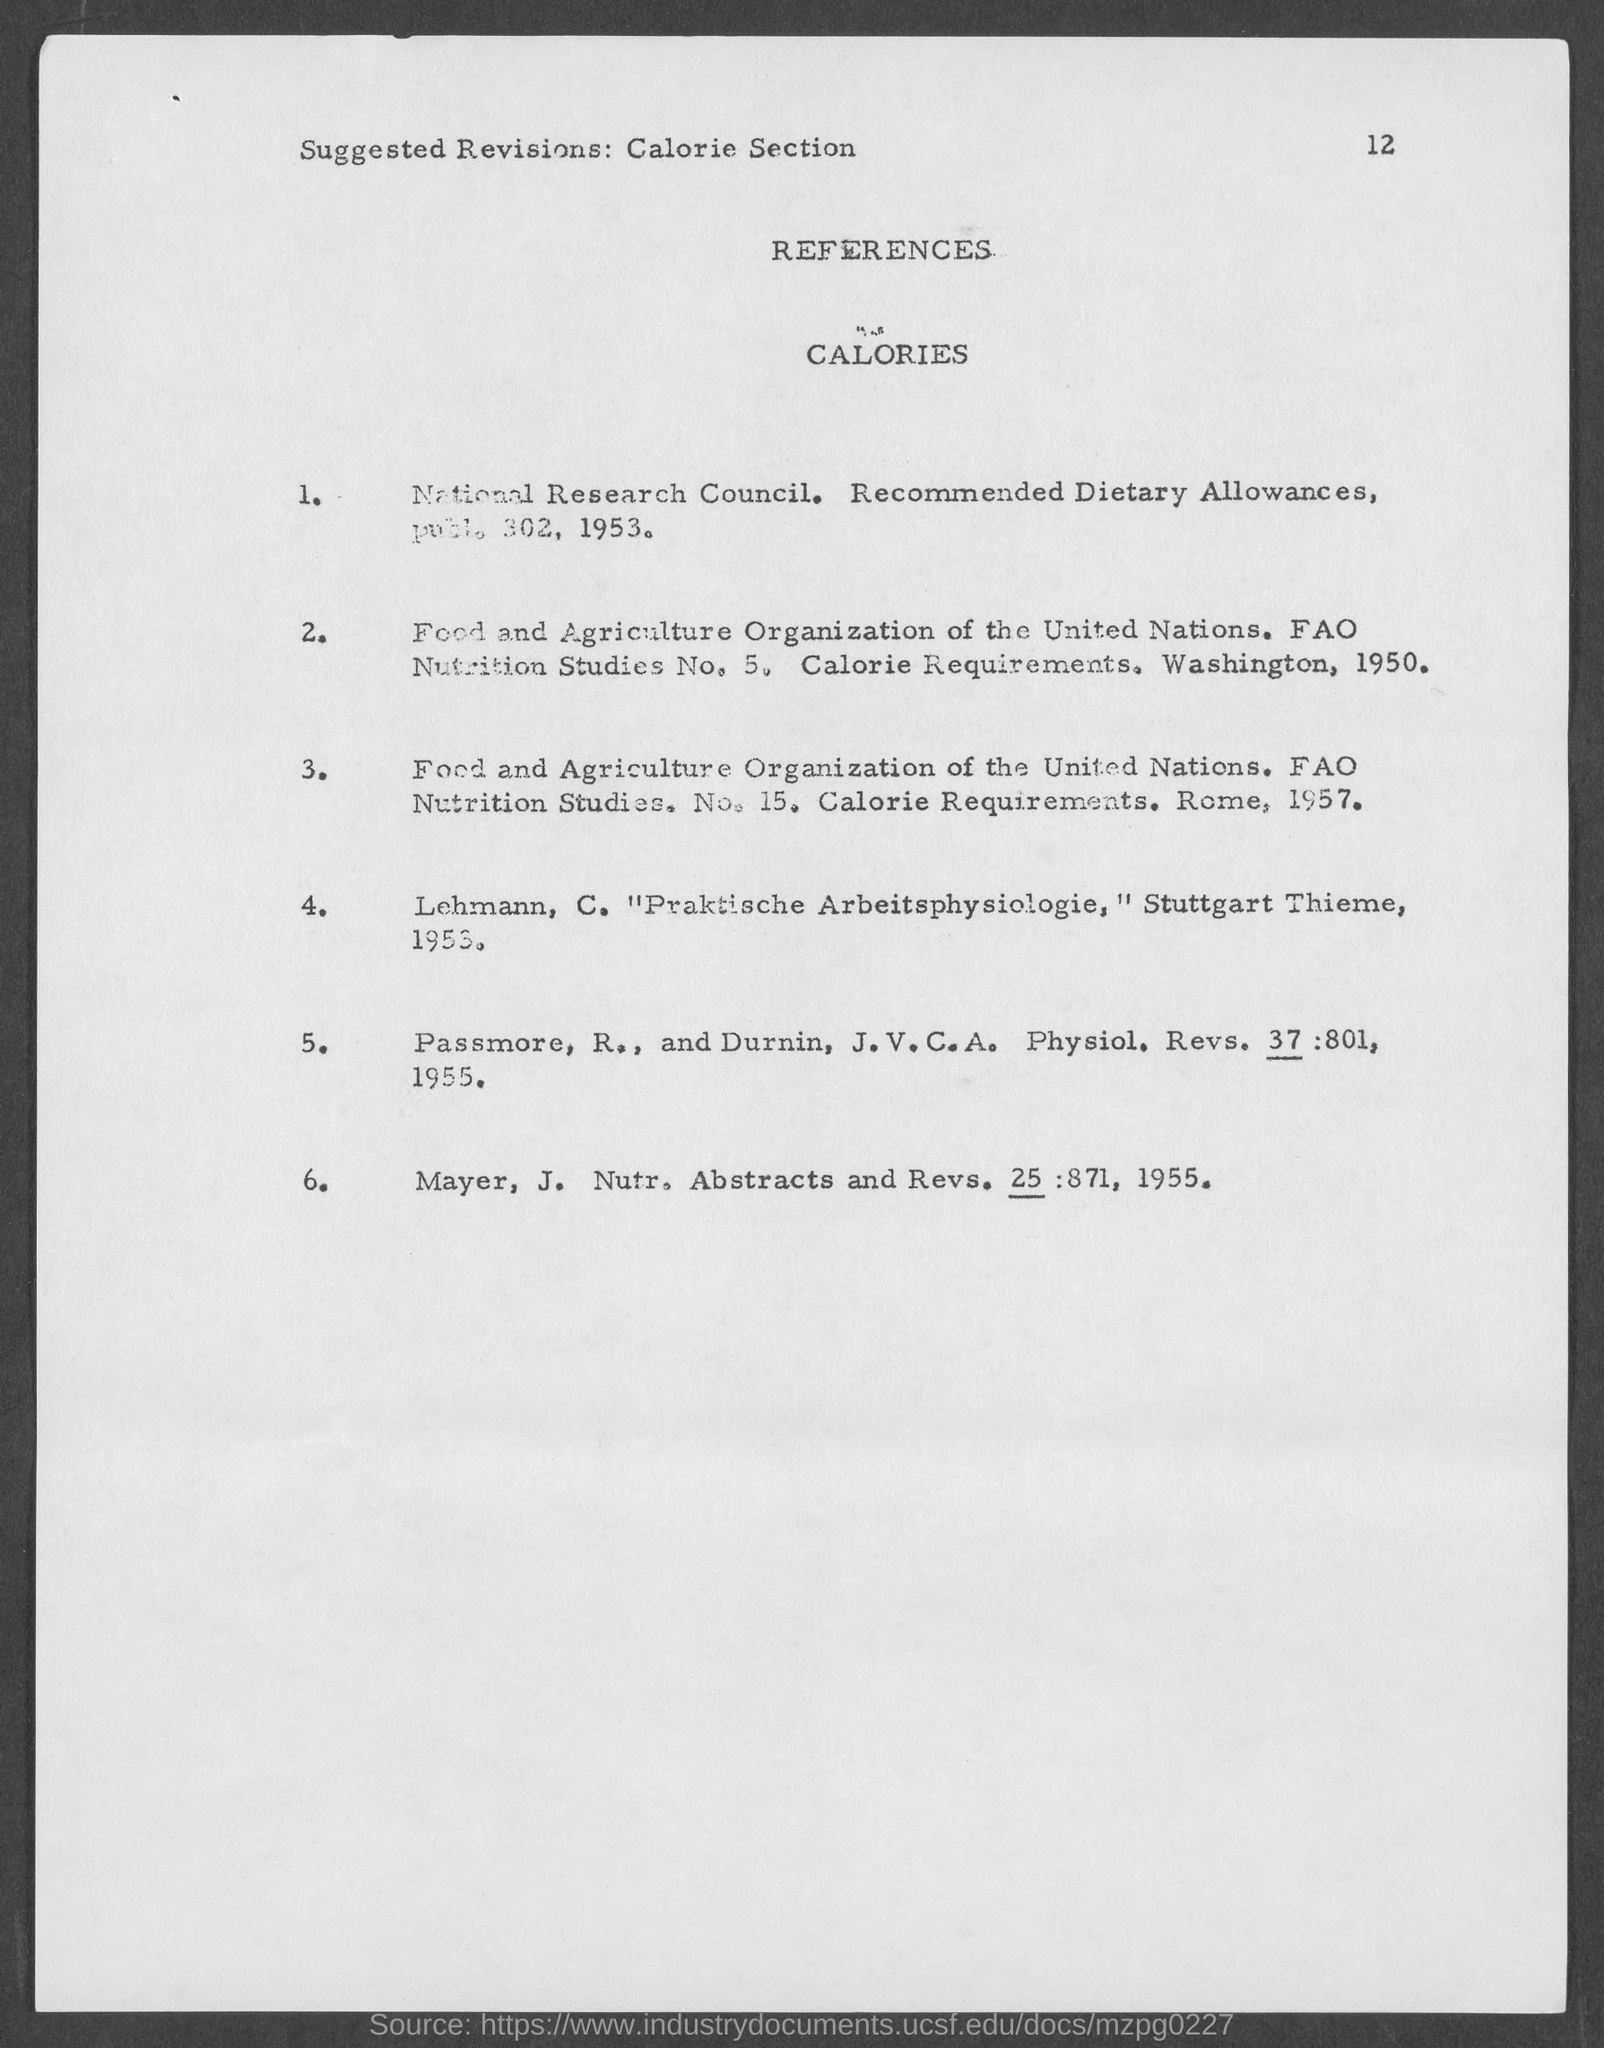What is the page no given in this document?
Your answer should be compact. 12. 